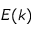Convert formula to latex. <formula><loc_0><loc_0><loc_500><loc_500>E ( k )</formula> 